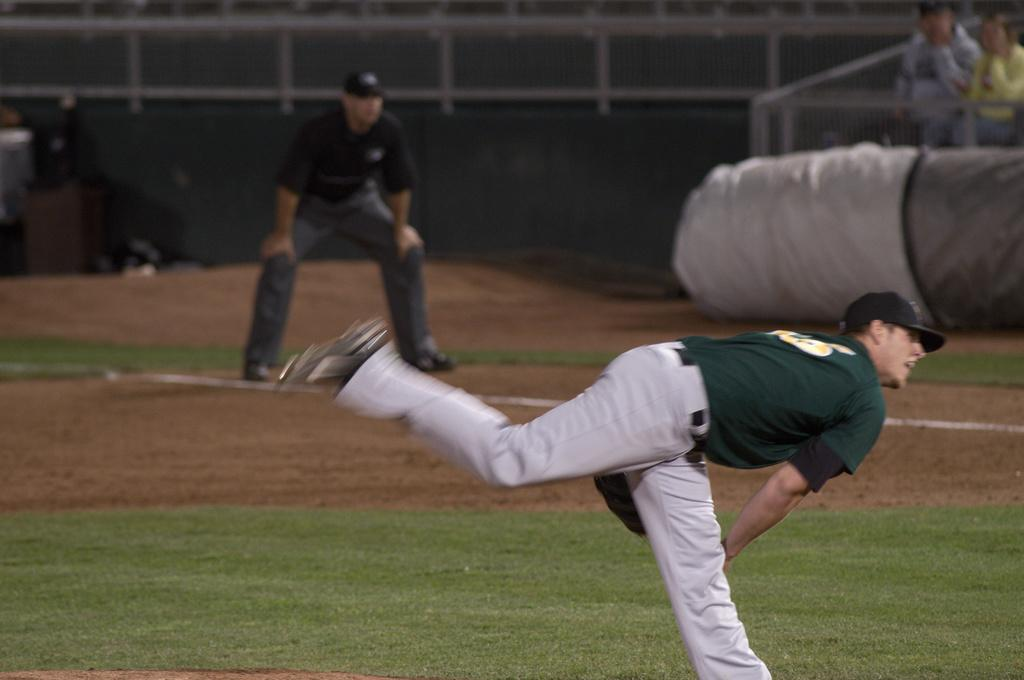What is the main subject of the image? There is a person in motion in the image. Can you describe the people in the background? There are three persons standing in the background of the image. What else can be seen in the image besides the people? There are some other items present in the image. What type of knowledge is the person in motion seeking in the image? There is no indication in the image that the person is seeking any specific knowledge. Can you tell me how many umbrellas are visible in the image? There is no umbrella present in the image. 